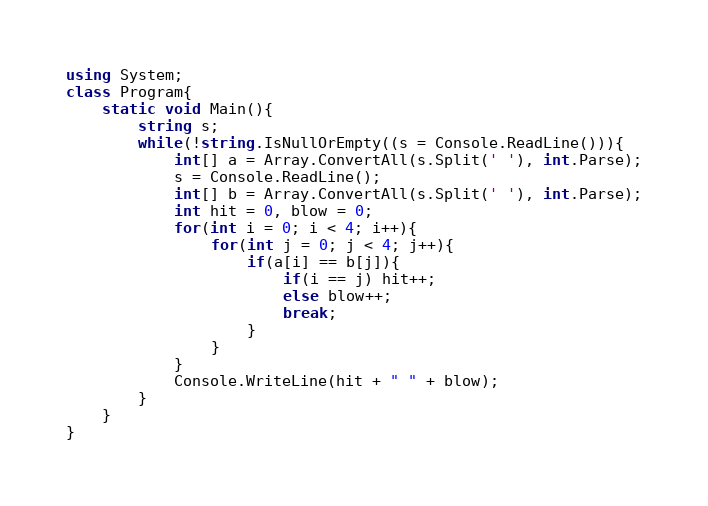Convert code to text. <code><loc_0><loc_0><loc_500><loc_500><_C#_>using System;
class Program{
	static void Main(){
		string s;
		while(!string.IsNullOrEmpty((s = Console.ReadLine())){
			int[] a = Array.ConvertAll(s.Split(' '), int.Parse);
			s = Console.ReadLine();
			int[] b = Array.ConvertAll(s.Split(' '), int.Parse);
			int hit = 0, blow = 0;
			for(int i = 0; i < 4; i++){
				for(int j = 0; j < 4; j++){
					if(a[i] == b[j]){
						if(i == j) hit++;
						else blow++;
						break;
					}
				}
			}
			Console.WriteLine(hit + " " + blow);
		}
	}
}</code> 